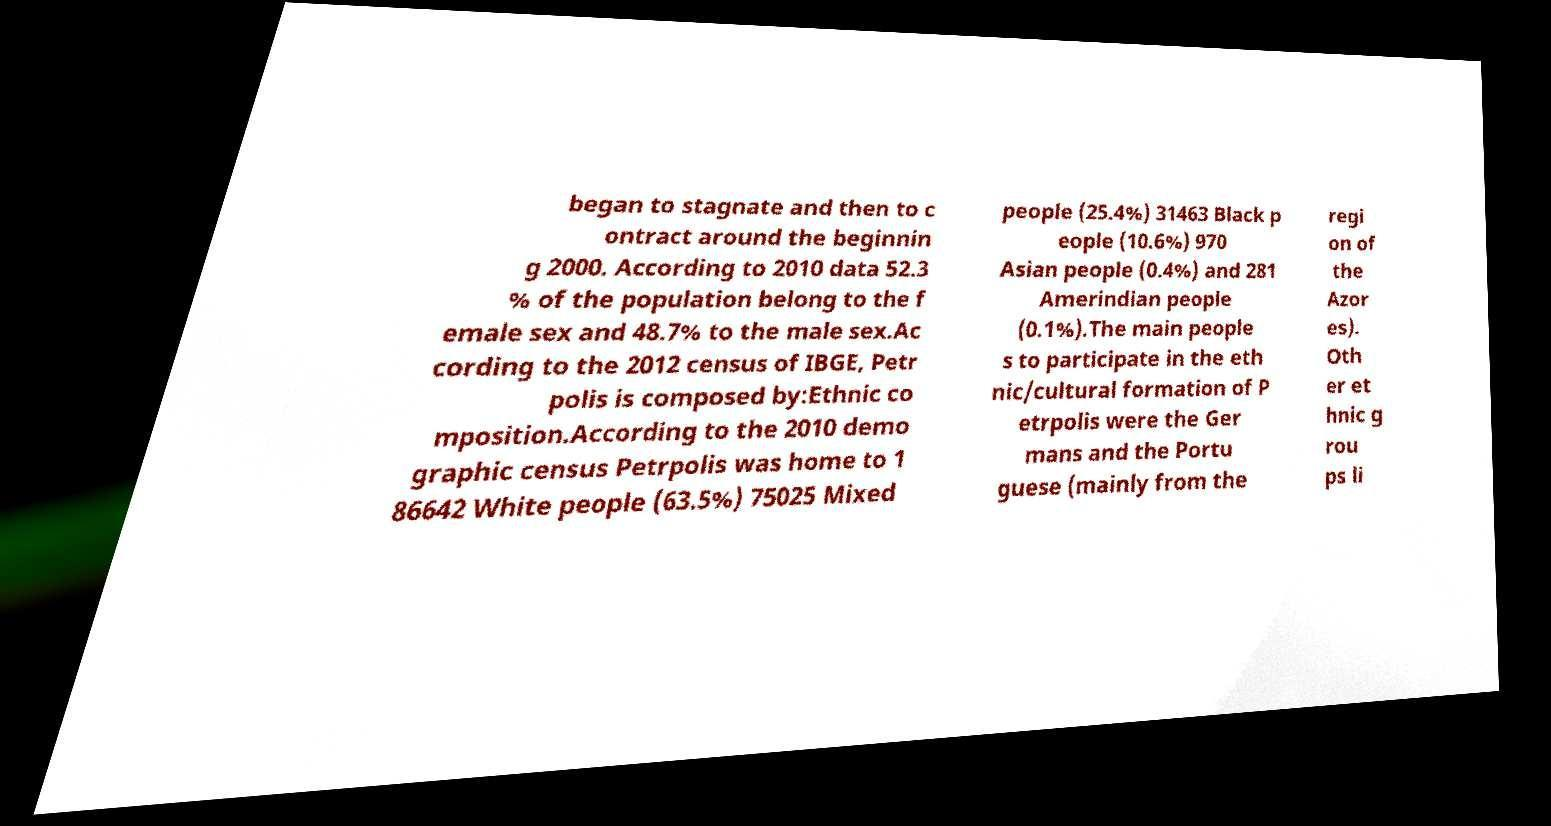What messages or text are displayed in this image? I need them in a readable, typed format. began to stagnate and then to c ontract around the beginnin g 2000. According to 2010 data 52.3 % of the population belong to the f emale sex and 48.7% to the male sex.Ac cording to the 2012 census of IBGE, Petr polis is composed by:Ethnic co mposition.According to the 2010 demo graphic census Petrpolis was home to 1 86642 White people (63.5%) 75025 Mixed people (25.4%) 31463 Black p eople (10.6%) 970 Asian people (0.4%) and 281 Amerindian people (0.1%).The main people s to participate in the eth nic/cultural formation of P etrpolis were the Ger mans and the Portu guese (mainly from the regi on of the Azor es). Oth er et hnic g rou ps li 